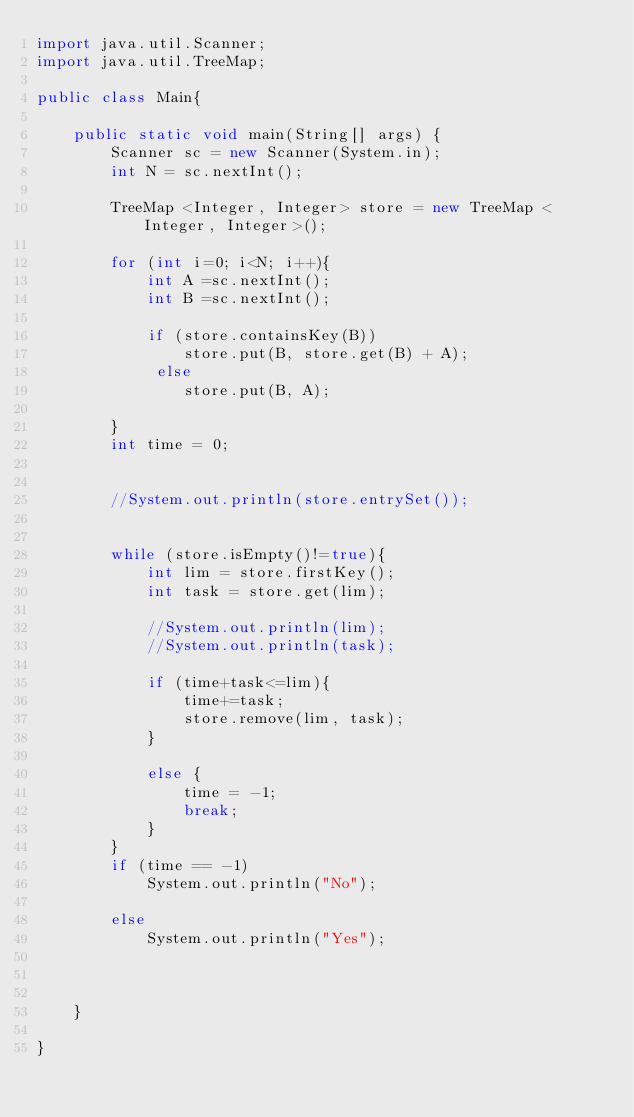<code> <loc_0><loc_0><loc_500><loc_500><_Java_>import java.util.Scanner;
import java.util.TreeMap;

public class Main{

	public static void main(String[] args) {
		Scanner sc = new Scanner(System.in);
	    int N = sc.nextInt();
	 
	    TreeMap <Integer, Integer> store = new TreeMap <Integer, Integer>();
	    
	    for (int i=0; i<N; i++){
	    	int A =sc.nextInt();
	    	int B =sc.nextInt();
	    	
	    	if (store.containsKey(B)) 
				store.put(B, store.get(B) + A);
			 else 
				store.put(B, A);
	    	
	    }
	    int time = 0;
	    
	   
	    //System.out.println(store.entrySet());
	    
	    
	    while (store.isEmpty()!=true){
	    	int lim = store.firstKey();
	    	int task = store.get(lim);
	    	
	    	//System.out.println(lim);
	    	//System.out.println(task);
	    	
	    	if (time+task<=lim){
	    		time+=task;
	    		store.remove(lim, task);
	    	}
	    	
	    	else {
	    		time = -1;
	    		break;
	    	}
	    }
	    if (time == -1)
	    	System.out.println("No");
	    
	    else
	    	System.out.println("Yes");
	    
	    

	}

}
</code> 